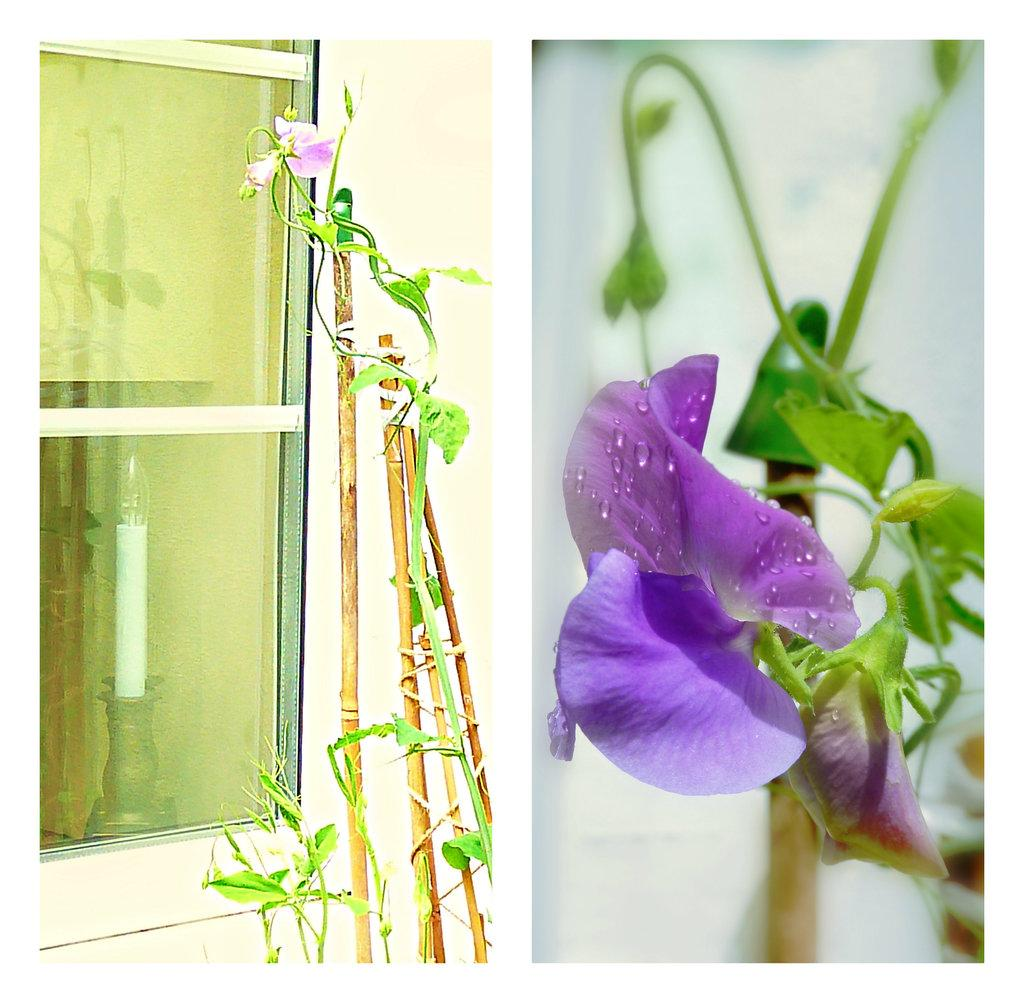What type of plants can be seen in the image? There are flowers and leaves in the image. What other objects are present in the image? There are sticks, a wall, and a glass window in the image. What can be seen through the glass window? A candle is visible through the window. What type of reward is being given to the person in the image? There is no person present in the image, and therefore no reward can be given. 